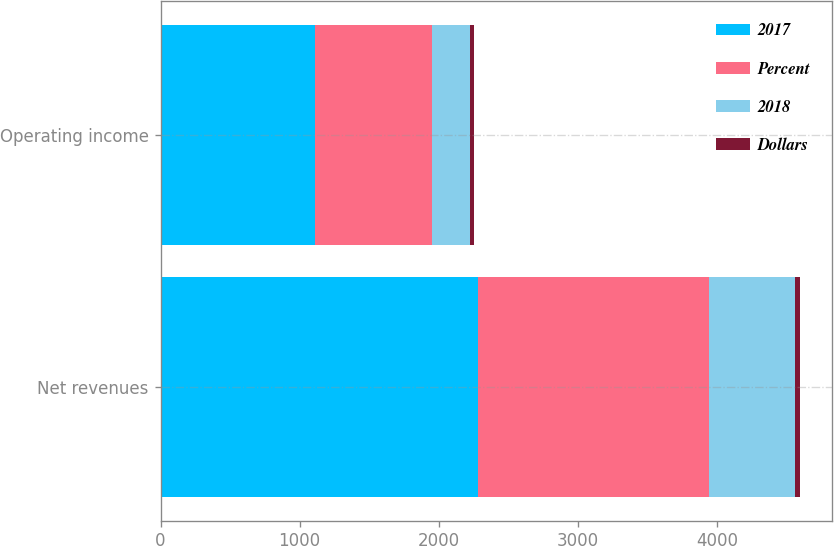<chart> <loc_0><loc_0><loc_500><loc_500><stacked_bar_chart><ecel><fcel>Net revenues<fcel>Operating income<nl><fcel>2017<fcel>2280<fcel>1111<nl><fcel>Percent<fcel>1664<fcel>839<nl><fcel>2018<fcel>616<fcel>272<nl><fcel>Dollars<fcel>37<fcel>32<nl></chart> 